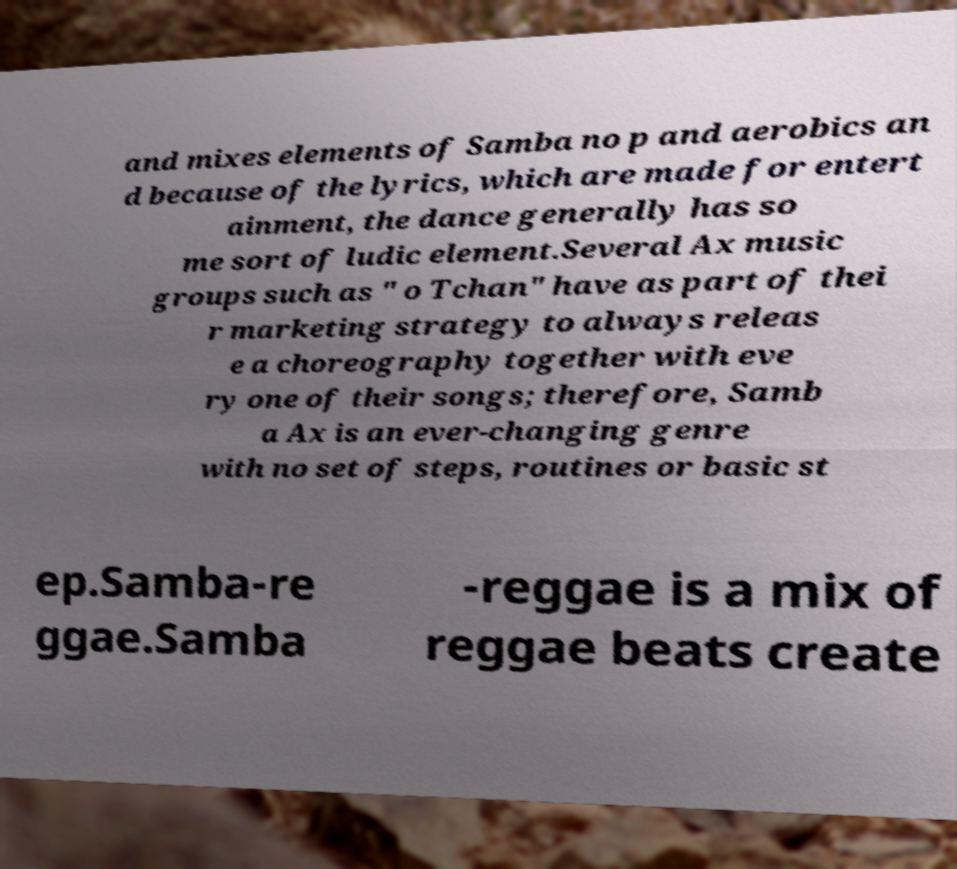Could you extract and type out the text from this image? and mixes elements of Samba no p and aerobics an d because of the lyrics, which are made for entert ainment, the dance generally has so me sort of ludic element.Several Ax music groups such as " o Tchan" have as part of thei r marketing strategy to always releas e a choreography together with eve ry one of their songs; therefore, Samb a Ax is an ever-changing genre with no set of steps, routines or basic st ep.Samba-re ggae.Samba -reggae is a mix of reggae beats create 